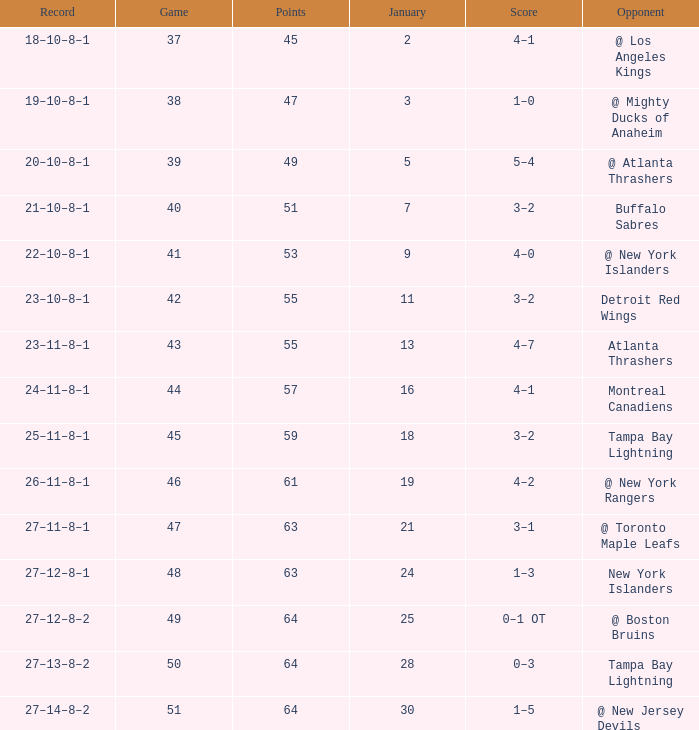How many Points have a January of 18? 1.0. 